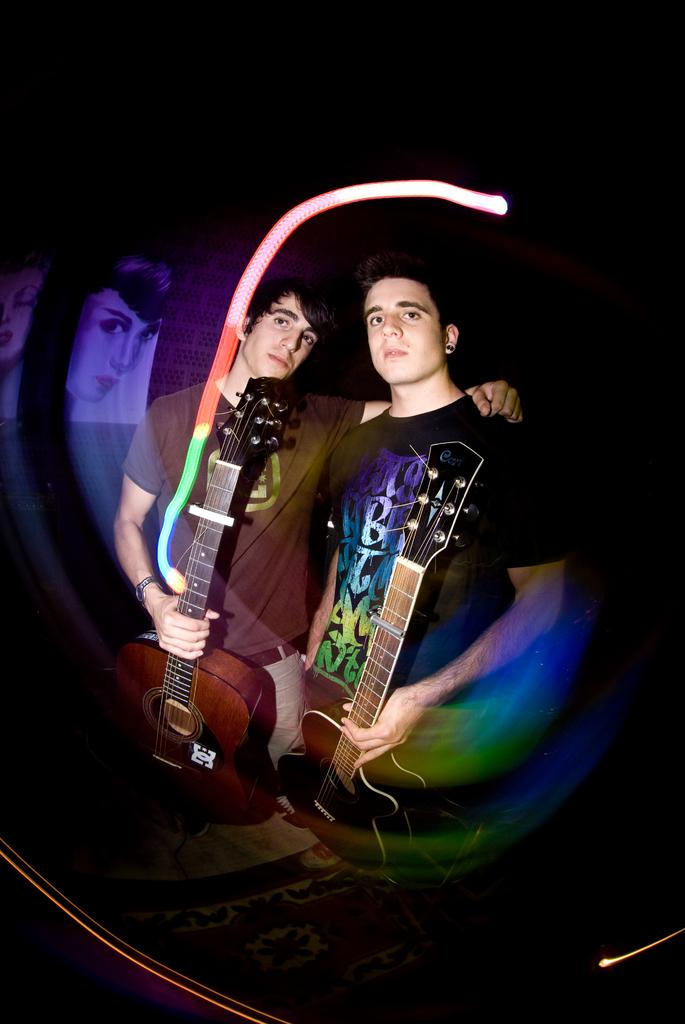How many people are in the image? There are two men in the image. What are the men doing in the image? The men are standing in the image. What are the men holding in their hands? The men are holding a guitar in their hands. What type of jelly can be seen on the ground near the men in the image? There is no jelly present in the image; it only features two men holding a guitar. 